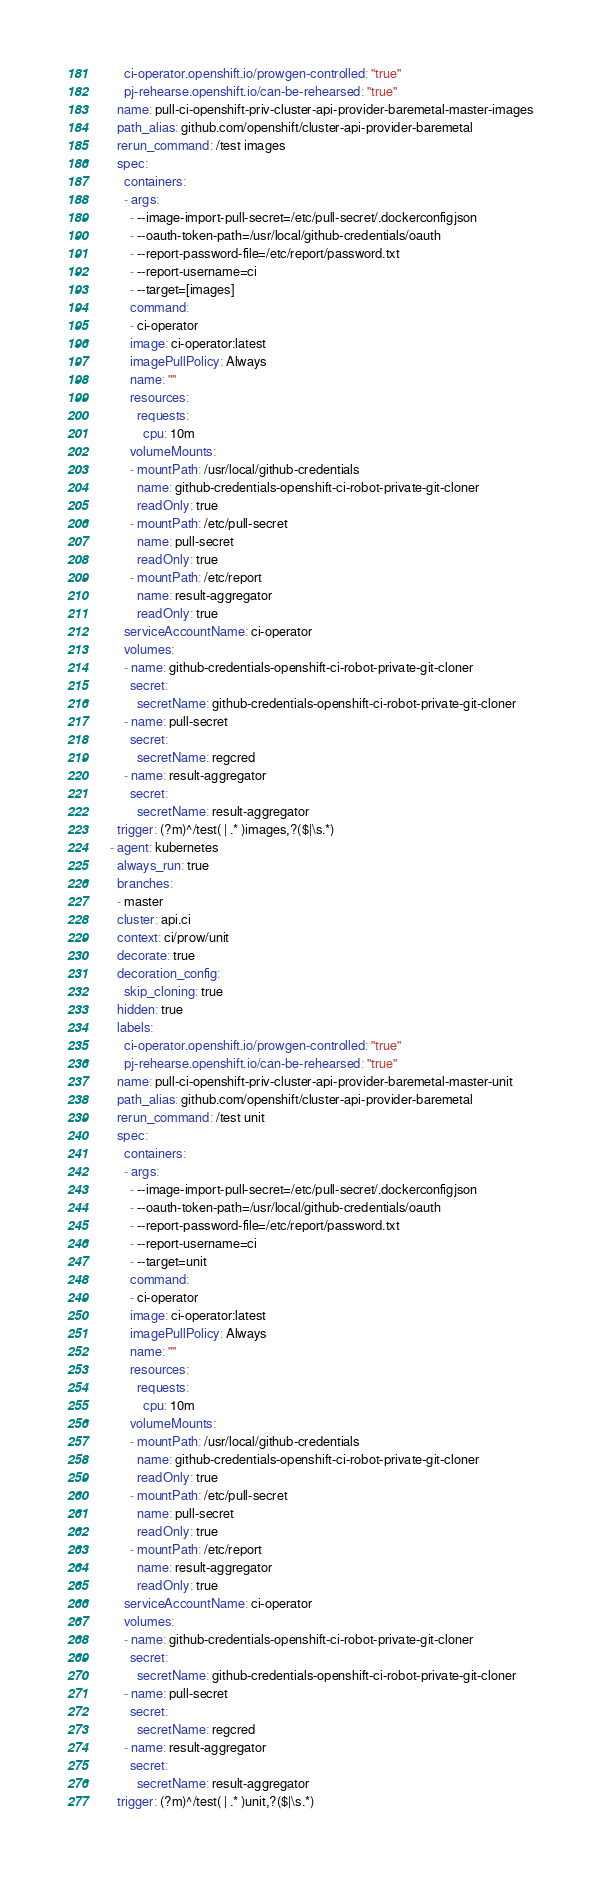Convert code to text. <code><loc_0><loc_0><loc_500><loc_500><_YAML_>      ci-operator.openshift.io/prowgen-controlled: "true"
      pj-rehearse.openshift.io/can-be-rehearsed: "true"
    name: pull-ci-openshift-priv-cluster-api-provider-baremetal-master-images
    path_alias: github.com/openshift/cluster-api-provider-baremetal
    rerun_command: /test images
    spec:
      containers:
      - args:
        - --image-import-pull-secret=/etc/pull-secret/.dockerconfigjson
        - --oauth-token-path=/usr/local/github-credentials/oauth
        - --report-password-file=/etc/report/password.txt
        - --report-username=ci
        - --target=[images]
        command:
        - ci-operator
        image: ci-operator:latest
        imagePullPolicy: Always
        name: ""
        resources:
          requests:
            cpu: 10m
        volumeMounts:
        - mountPath: /usr/local/github-credentials
          name: github-credentials-openshift-ci-robot-private-git-cloner
          readOnly: true
        - mountPath: /etc/pull-secret
          name: pull-secret
          readOnly: true
        - mountPath: /etc/report
          name: result-aggregator
          readOnly: true
      serviceAccountName: ci-operator
      volumes:
      - name: github-credentials-openshift-ci-robot-private-git-cloner
        secret:
          secretName: github-credentials-openshift-ci-robot-private-git-cloner
      - name: pull-secret
        secret:
          secretName: regcred
      - name: result-aggregator
        secret:
          secretName: result-aggregator
    trigger: (?m)^/test( | .* )images,?($|\s.*)
  - agent: kubernetes
    always_run: true
    branches:
    - master
    cluster: api.ci
    context: ci/prow/unit
    decorate: true
    decoration_config:
      skip_cloning: true
    hidden: true
    labels:
      ci-operator.openshift.io/prowgen-controlled: "true"
      pj-rehearse.openshift.io/can-be-rehearsed: "true"
    name: pull-ci-openshift-priv-cluster-api-provider-baremetal-master-unit
    path_alias: github.com/openshift/cluster-api-provider-baremetal
    rerun_command: /test unit
    spec:
      containers:
      - args:
        - --image-import-pull-secret=/etc/pull-secret/.dockerconfigjson
        - --oauth-token-path=/usr/local/github-credentials/oauth
        - --report-password-file=/etc/report/password.txt
        - --report-username=ci
        - --target=unit
        command:
        - ci-operator
        image: ci-operator:latest
        imagePullPolicy: Always
        name: ""
        resources:
          requests:
            cpu: 10m
        volumeMounts:
        - mountPath: /usr/local/github-credentials
          name: github-credentials-openshift-ci-robot-private-git-cloner
          readOnly: true
        - mountPath: /etc/pull-secret
          name: pull-secret
          readOnly: true
        - mountPath: /etc/report
          name: result-aggregator
          readOnly: true
      serviceAccountName: ci-operator
      volumes:
      - name: github-credentials-openshift-ci-robot-private-git-cloner
        secret:
          secretName: github-credentials-openshift-ci-robot-private-git-cloner
      - name: pull-secret
        secret:
          secretName: regcred
      - name: result-aggregator
        secret:
          secretName: result-aggregator
    trigger: (?m)^/test( | .* )unit,?($|\s.*)
</code> 